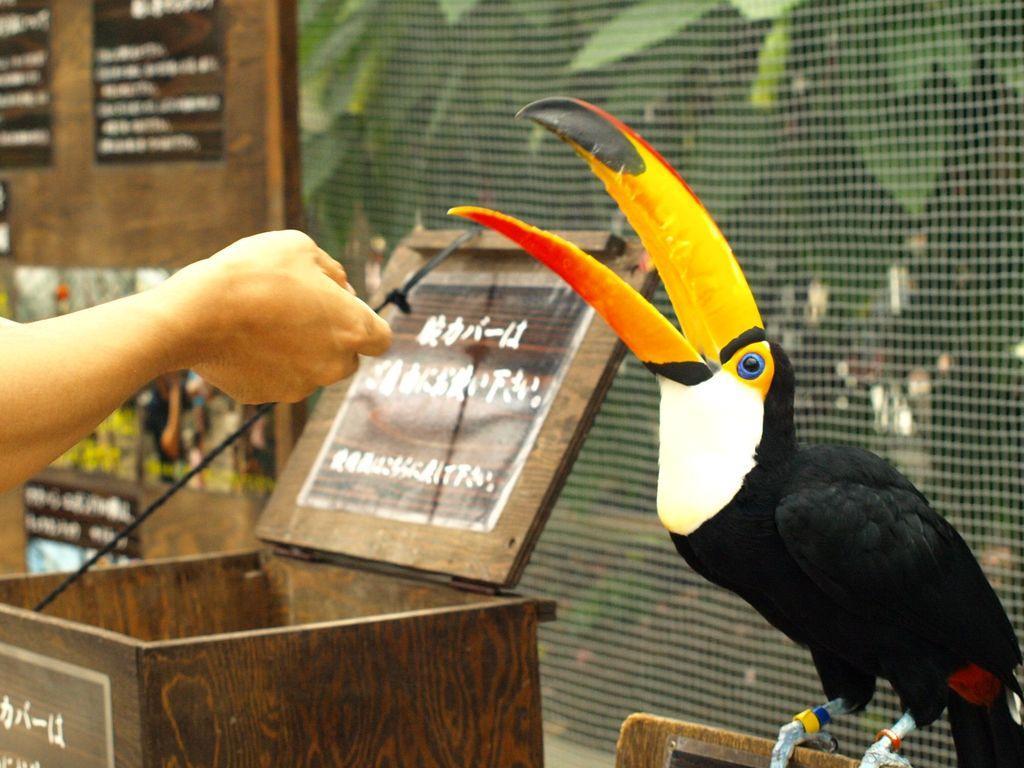How would you summarize this image in a sentence or two? In this image we can see a bird. There is a box and few posters on it in the image. There is a notice board at the left side of the image. There are few plants in the image. There is a fence in the image. We can see a person's hand and an object in the hand in the image. 